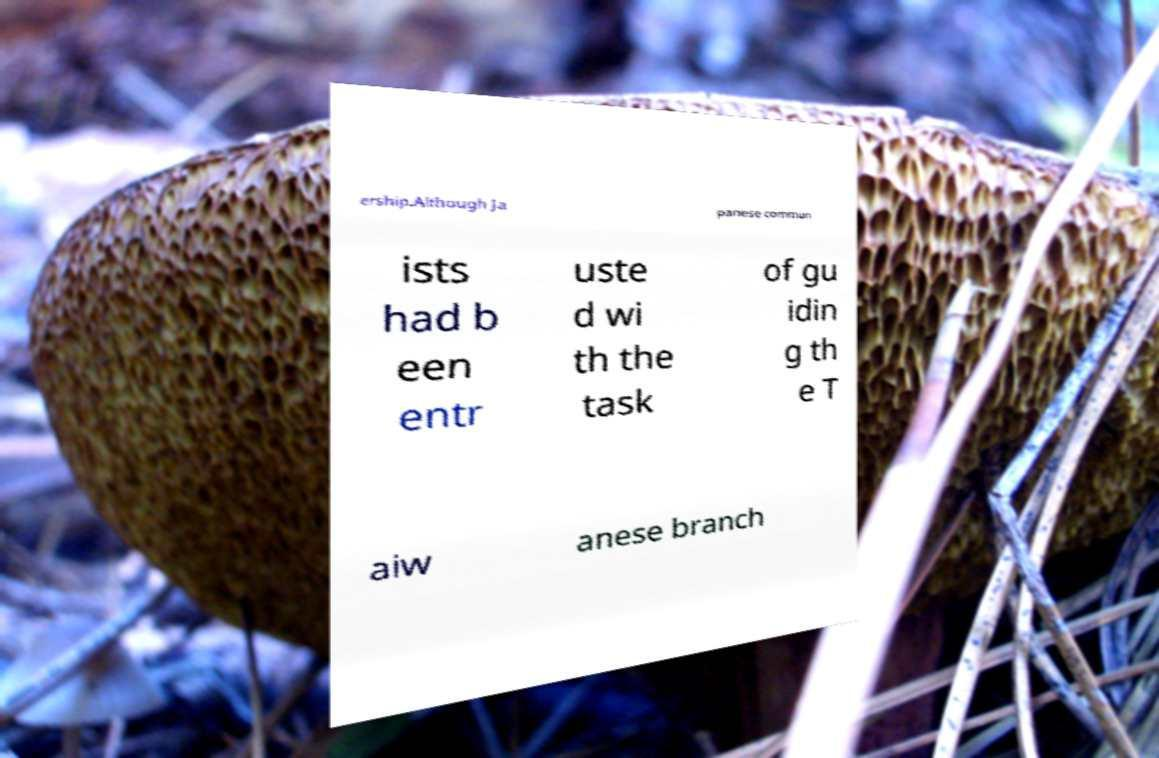There's text embedded in this image that I need extracted. Can you transcribe it verbatim? ership.Although Ja panese commun ists had b een entr uste d wi th the task of gu idin g th e T aiw anese branch 